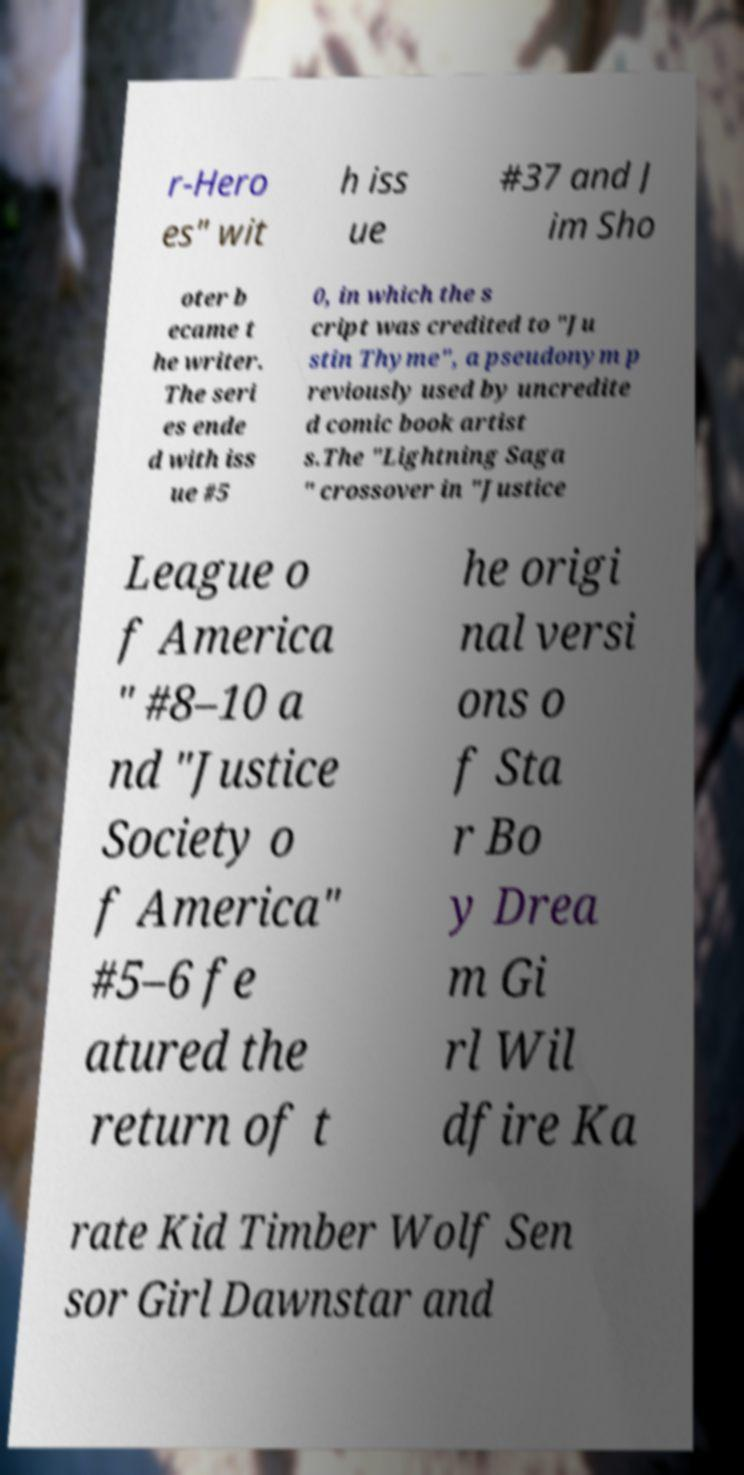Could you extract and type out the text from this image? r-Hero es" wit h iss ue #37 and J im Sho oter b ecame t he writer. The seri es ende d with iss ue #5 0, in which the s cript was credited to "Ju stin Thyme", a pseudonym p reviously used by uncredite d comic book artist s.The "Lightning Saga " crossover in "Justice League o f America " #8–10 a nd "Justice Society o f America" #5–6 fe atured the return of t he origi nal versi ons o f Sta r Bo y Drea m Gi rl Wil dfire Ka rate Kid Timber Wolf Sen sor Girl Dawnstar and 